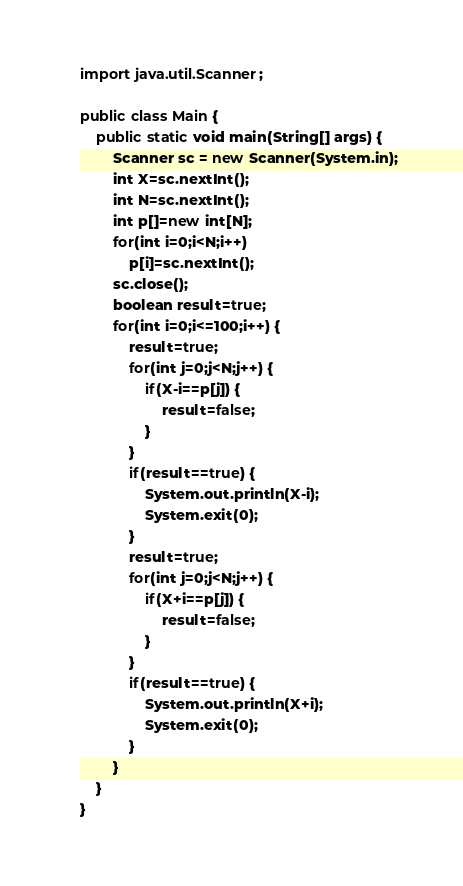Convert code to text. <code><loc_0><loc_0><loc_500><loc_500><_Java_>import java.util.Scanner;

public class Main {
	public static void main(String[] args) {
		Scanner sc = new Scanner(System.in);
		int X=sc.nextInt();
		int N=sc.nextInt();
		int p[]=new int[N];
		for(int i=0;i<N;i++) 
			p[i]=sc.nextInt();
		sc.close();
		boolean result=true;
		for(int i=0;i<=100;i++) {
			result=true;
			for(int j=0;j<N;j++) {
				if(X-i==p[j]) {
					result=false;
				}
			}
			if(result==true) {
				System.out.println(X-i);
				System.exit(0);
			}
			result=true;
			for(int j=0;j<N;j++) {
				if(X+i==p[j]) {
					result=false;
				}
			}
			if(result==true) {
				System.out.println(X+i);
				System.exit(0);
			}
		}	
	}
}</code> 